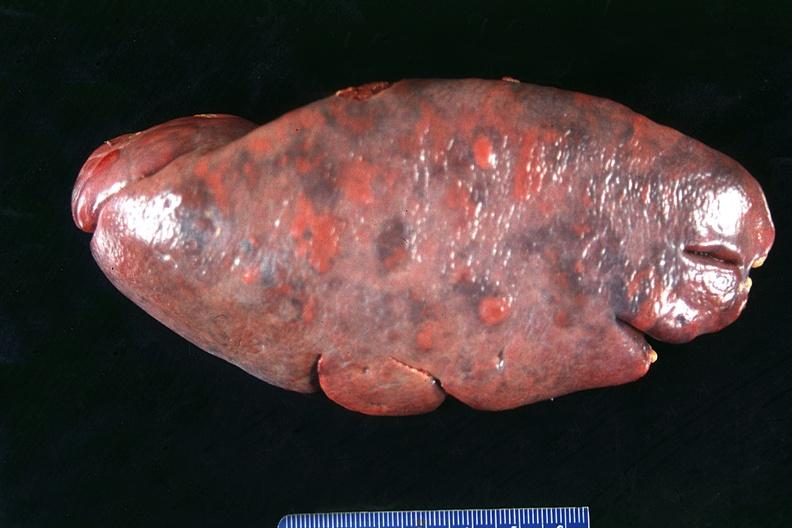s hematologic present?
Answer the question using a single word or phrase. Yes 